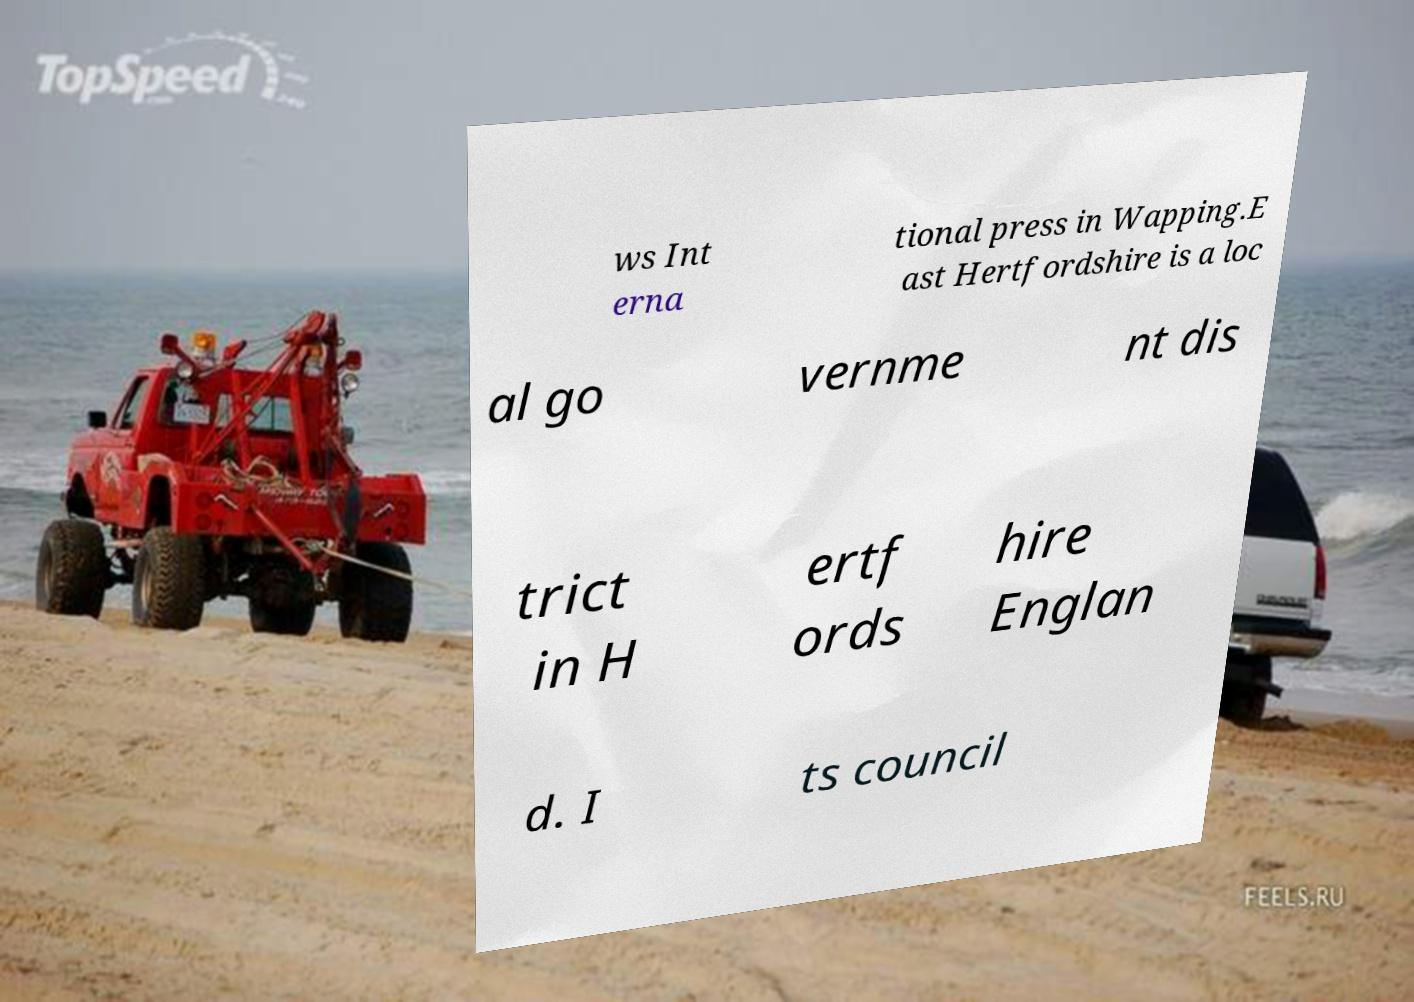Please read and relay the text visible in this image. What does it say? ws Int erna tional press in Wapping.E ast Hertfordshire is a loc al go vernme nt dis trict in H ertf ords hire Englan d. I ts council 